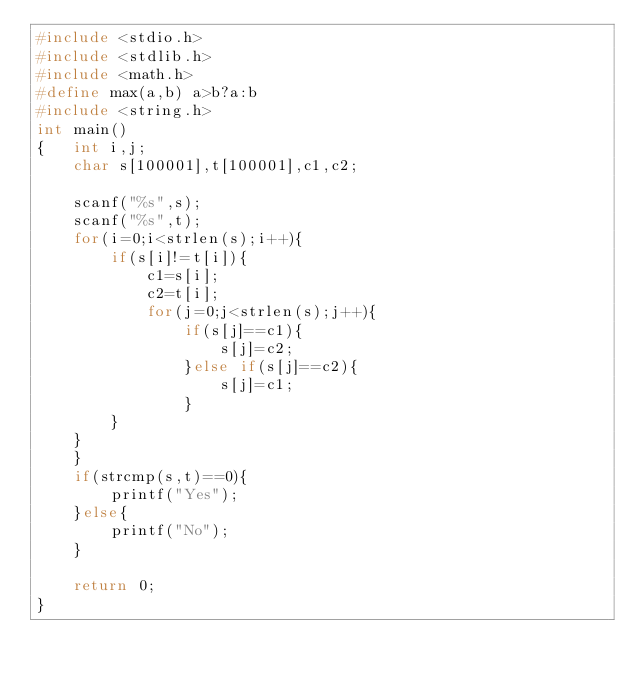<code> <loc_0><loc_0><loc_500><loc_500><_C_>#include <stdio.h>
#include <stdlib.h>
#include <math.h>
#define max(a,b) a>b?a:b
#include <string.h>
int main()
{   int i,j;
    char s[100001],t[100001],c1,c2;

    scanf("%s",s);
    scanf("%s",t);
    for(i=0;i<strlen(s);i++){
        if(s[i]!=t[i]){
            c1=s[i];
            c2=t[i];
            for(j=0;j<strlen(s);j++){
                if(s[j]==c1){
                    s[j]=c2;
                }else if(s[j]==c2){
                    s[j]=c1;
                }
        }
    }
    }
    if(strcmp(s,t)==0){
        printf("Yes");
    }else{
        printf("No");
    }

    return 0;
}
</code> 